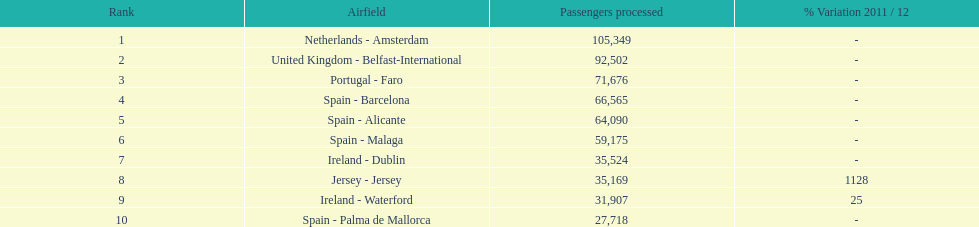How many airports in spain are among the 10 busiest routes to and from london southend airport in 2012? 4. 